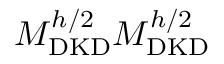<formula> <loc_0><loc_0><loc_500><loc_500>M _ { D K D } ^ { h / 2 } M _ { D K D } ^ { h / 2 }</formula> 